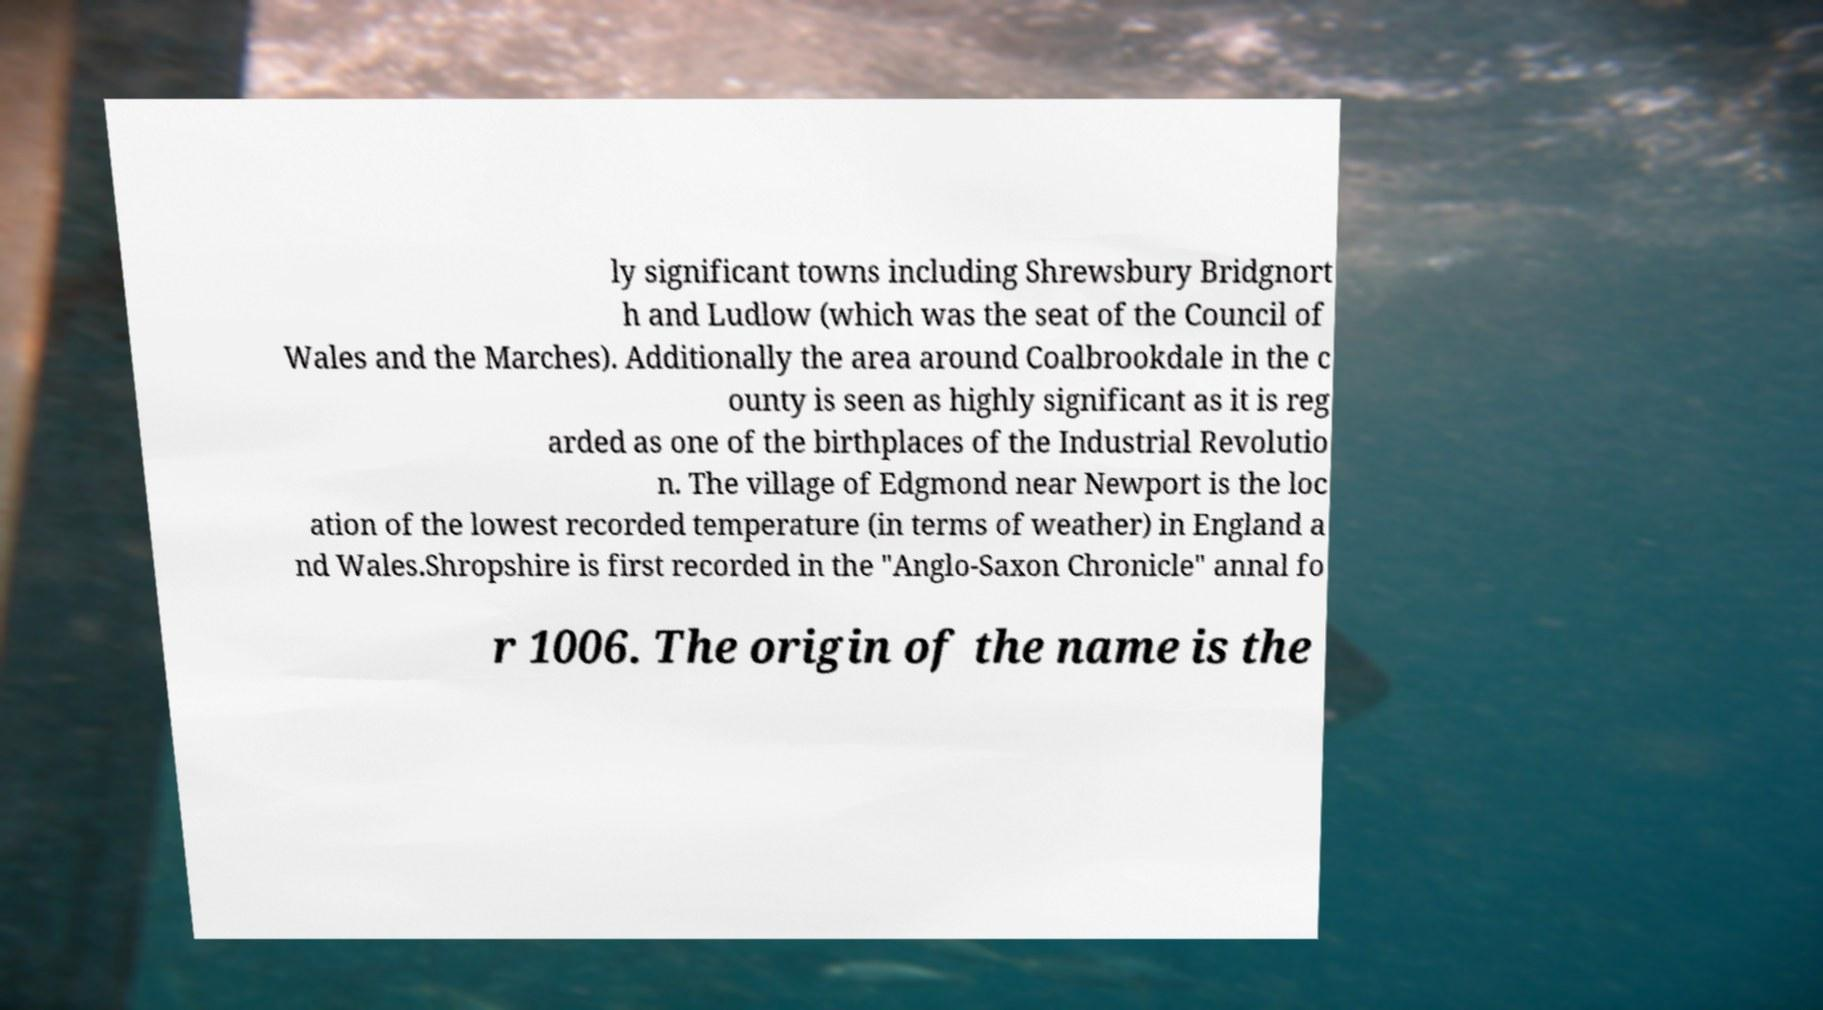Can you read and provide the text displayed in the image?This photo seems to have some interesting text. Can you extract and type it out for me? ly significant towns including Shrewsbury Bridgnort h and Ludlow (which was the seat of the Council of Wales and the Marches). Additionally the area around Coalbrookdale in the c ounty is seen as highly significant as it is reg arded as one of the birthplaces of the Industrial Revolutio n. The village of Edgmond near Newport is the loc ation of the lowest recorded temperature (in terms of weather) in England a nd Wales.Shropshire is first recorded in the "Anglo-Saxon Chronicle" annal fo r 1006. The origin of the name is the 